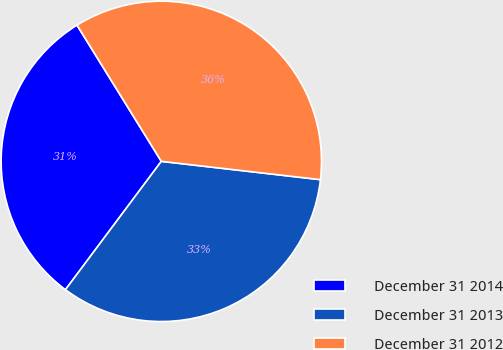Convert chart to OTSL. <chart><loc_0><loc_0><loc_500><loc_500><pie_chart><fcel>December 31 2014<fcel>December 31 2013<fcel>December 31 2012<nl><fcel>30.97%<fcel>33.39%<fcel>35.65%<nl></chart> 